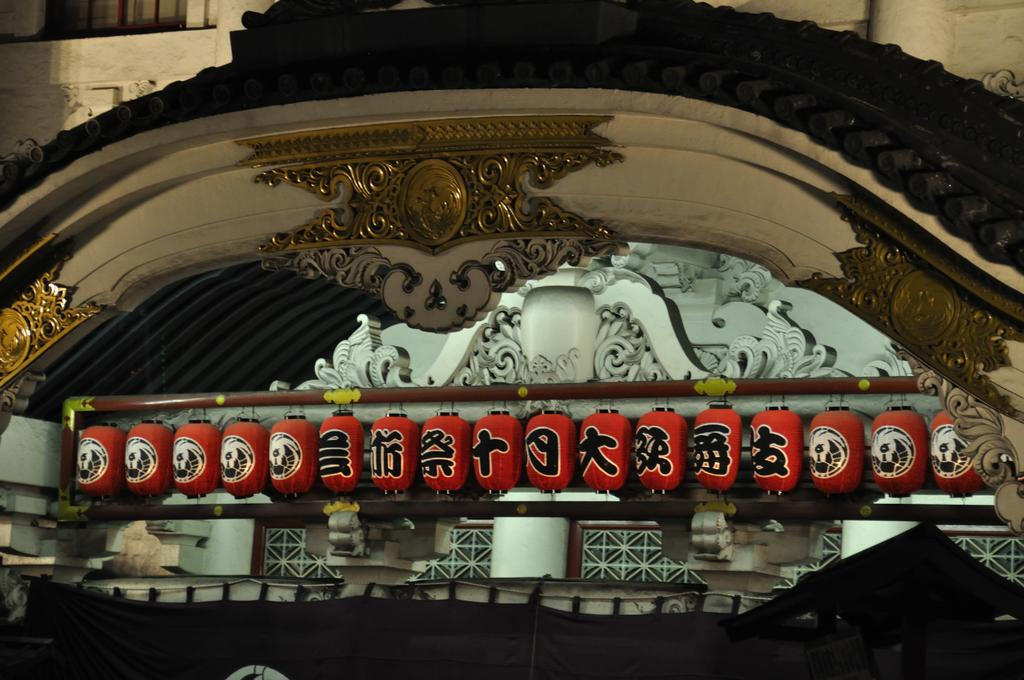What is the main structure or object in the image? There is a shrine in the image. What can be seen on the walls of the shrine? There is a sculpture on the walls in the image. Can you see a trail of kittens leading up to the shrine in the image? There is no trail of kittens present in the image. Is the shrine located in space in the image? The image does not depict the shrine in space; it is located on Earth. 